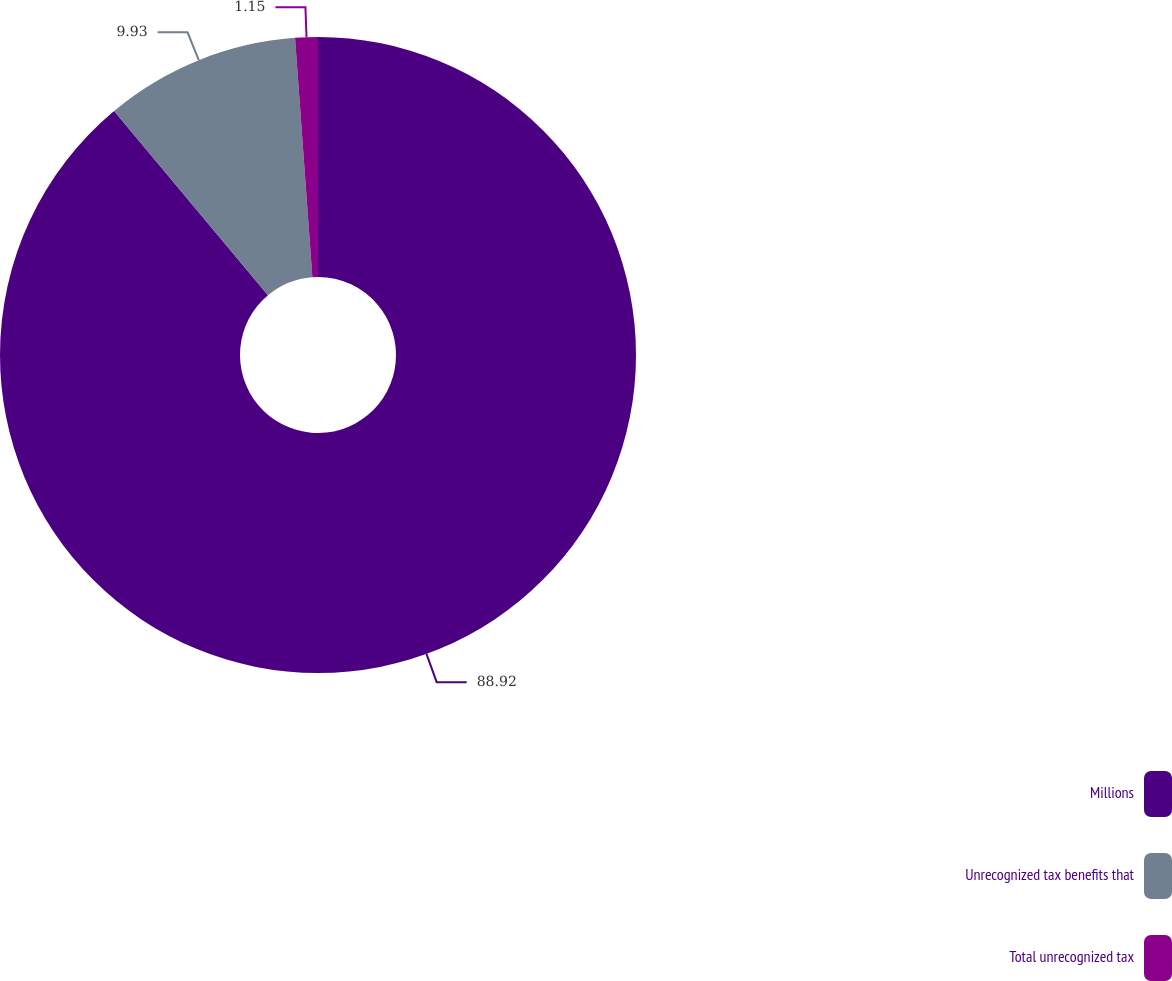Convert chart. <chart><loc_0><loc_0><loc_500><loc_500><pie_chart><fcel>Millions<fcel>Unrecognized tax benefits that<fcel>Total unrecognized tax<nl><fcel>88.92%<fcel>9.93%<fcel>1.15%<nl></chart> 